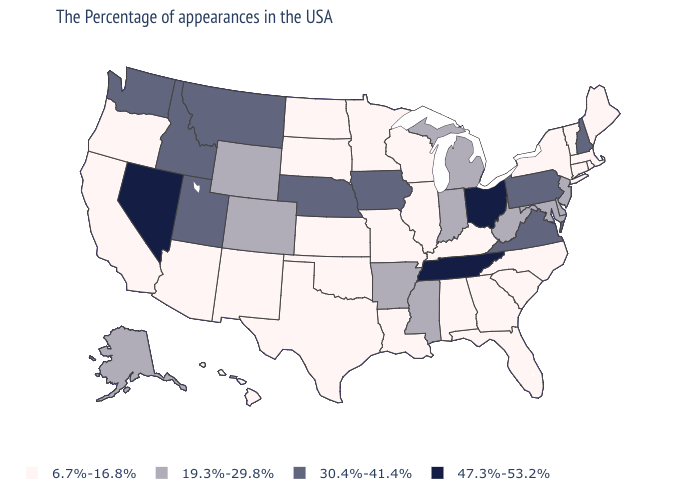Which states have the lowest value in the USA?
Quick response, please. Maine, Massachusetts, Rhode Island, Vermont, Connecticut, New York, North Carolina, South Carolina, Florida, Georgia, Kentucky, Alabama, Wisconsin, Illinois, Louisiana, Missouri, Minnesota, Kansas, Oklahoma, Texas, South Dakota, North Dakota, New Mexico, Arizona, California, Oregon, Hawaii. What is the lowest value in the USA?
Write a very short answer. 6.7%-16.8%. Does Vermont have the lowest value in the USA?
Quick response, please. Yes. Is the legend a continuous bar?
Write a very short answer. No. What is the highest value in the Northeast ?
Quick response, please. 30.4%-41.4%. Does the first symbol in the legend represent the smallest category?
Answer briefly. Yes. Among the states that border Indiana , does Kentucky have the highest value?
Be succinct. No. Name the states that have a value in the range 6.7%-16.8%?
Short answer required. Maine, Massachusetts, Rhode Island, Vermont, Connecticut, New York, North Carolina, South Carolina, Florida, Georgia, Kentucky, Alabama, Wisconsin, Illinois, Louisiana, Missouri, Minnesota, Kansas, Oklahoma, Texas, South Dakota, North Dakota, New Mexico, Arizona, California, Oregon, Hawaii. What is the highest value in the USA?
Keep it brief. 47.3%-53.2%. Name the states that have a value in the range 19.3%-29.8%?
Write a very short answer. New Jersey, Delaware, Maryland, West Virginia, Michigan, Indiana, Mississippi, Arkansas, Wyoming, Colorado, Alaska. How many symbols are there in the legend?
Be succinct. 4. What is the value of Illinois?
Quick response, please. 6.7%-16.8%. Does the map have missing data?
Quick response, please. No. Name the states that have a value in the range 47.3%-53.2%?
Give a very brief answer. Ohio, Tennessee, Nevada. Name the states that have a value in the range 47.3%-53.2%?
Keep it brief. Ohio, Tennessee, Nevada. 